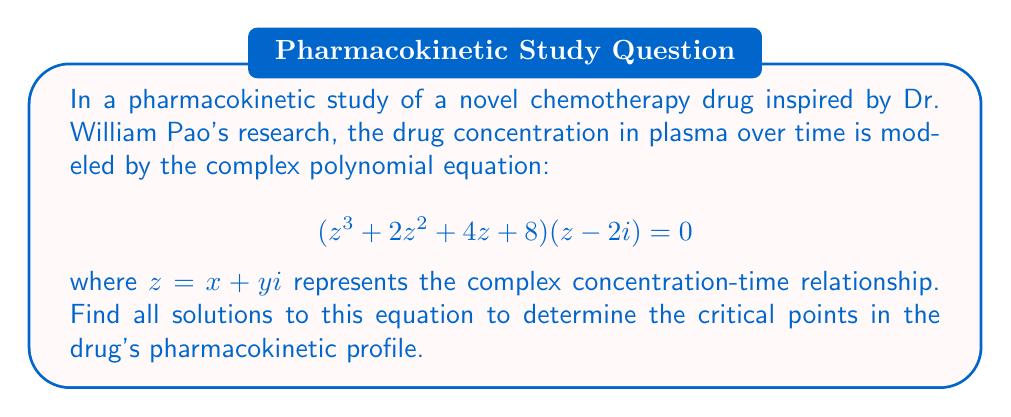What is the answer to this math problem? Let's solve this step-by-step:

1) First, we can factor the equation:
   $$(z^3 + 2z^2 + 4z + 8)(z - 2i) = 0$$

2) By the zero product property, either $(z^3 + 2z^2 + 4z + 8) = 0$ or $(z - 2i) = 0$

3) Let's solve $(z - 2i) = 0$ first:
   $z = 2i$

4) Now, let's focus on the cubic equation: $z^3 + 2z^2 + 4z + 8 = 0$

5) This is a complex cubic equation. We can solve it using the cubic formula, but it's complicated. Instead, let's use the rational root theorem to find one root, then factor.

6) Possible rational roots are factors of 8: $\pm1, \pm2, \pm4, \pm8$

7) Testing these, we find that $z = -2$ is a root.

8) Factoring out $(z + 2)$:
   $(z + 2)(z^2 + 4) = 0$

9) Now we have:
   $(z + 2)(z^2 + 4) = 0$

10) Solving $z^2 + 4 = 0$:
    $z^2 = -4$
    $z = \pm2i$

11) Therefore, the solutions are:
    $z = -2, 2i, -2i, 2i$ (note that $2i$ appears twice)

These solutions represent the critical points in the drug's pharmacokinetic profile, including potential absorption, distribution, and elimination phases.
Answer: $z = -2, 2i, -2i, 2i$ 